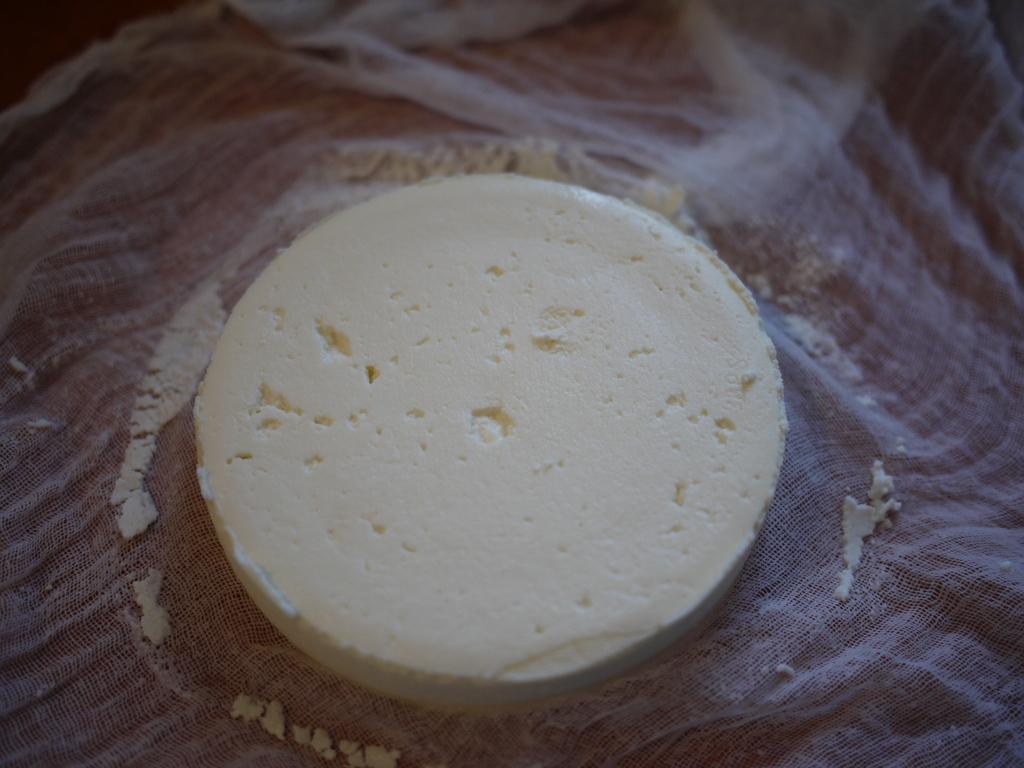Describe this image in one or two sentences. In this image there is a piece of tofu on the white cloth. 